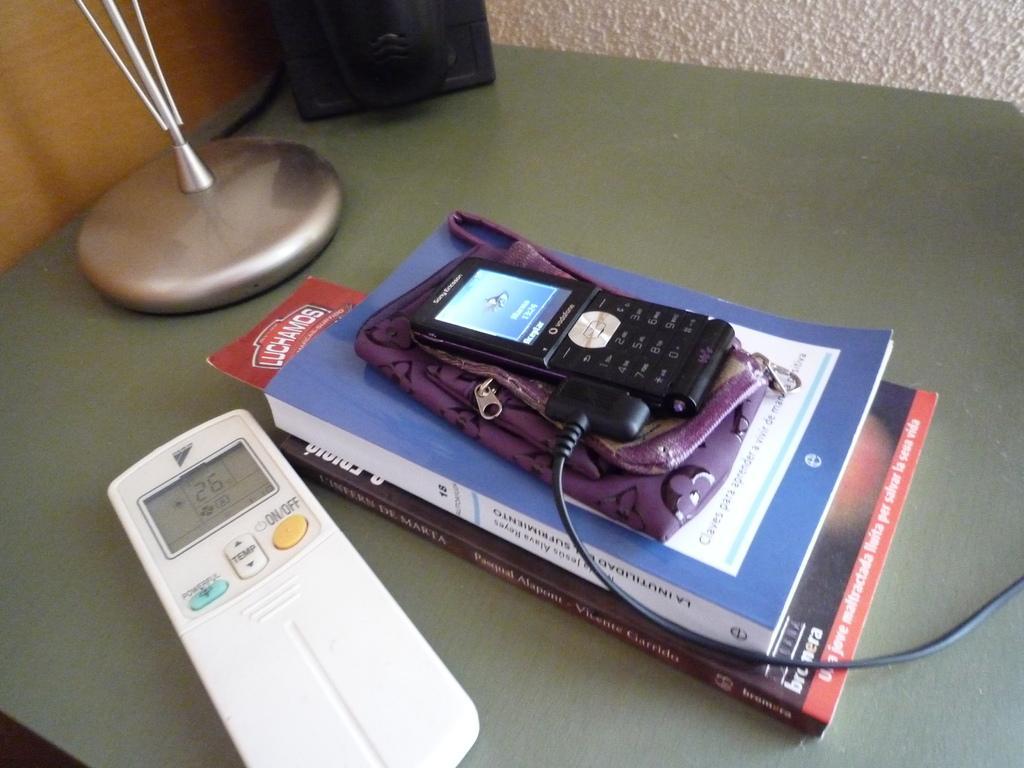Please provide a concise description of this image. In this image we can see the mobile phone, books, remote and some other objects on the wooden surface. 